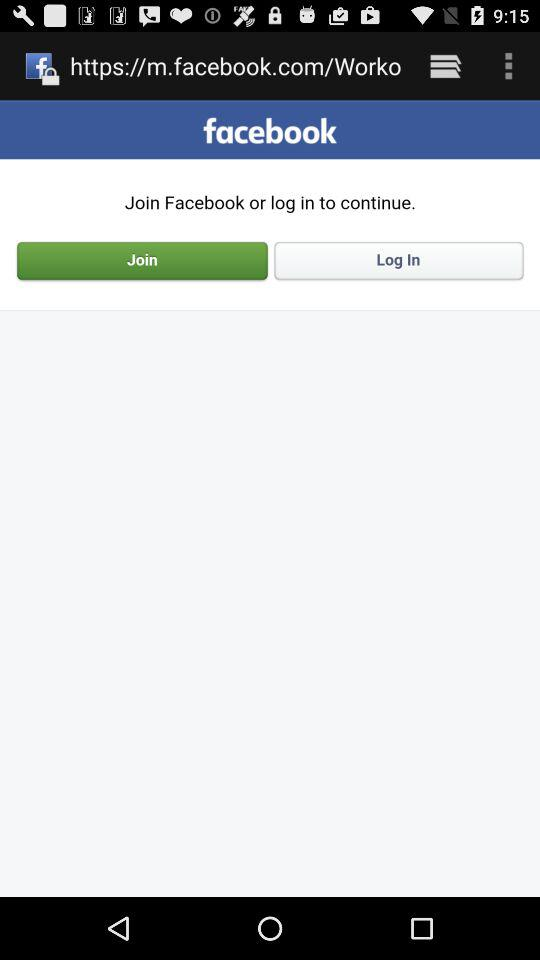What is the username?
When the provided information is insufficient, respond with <no answer>. <no answer> 